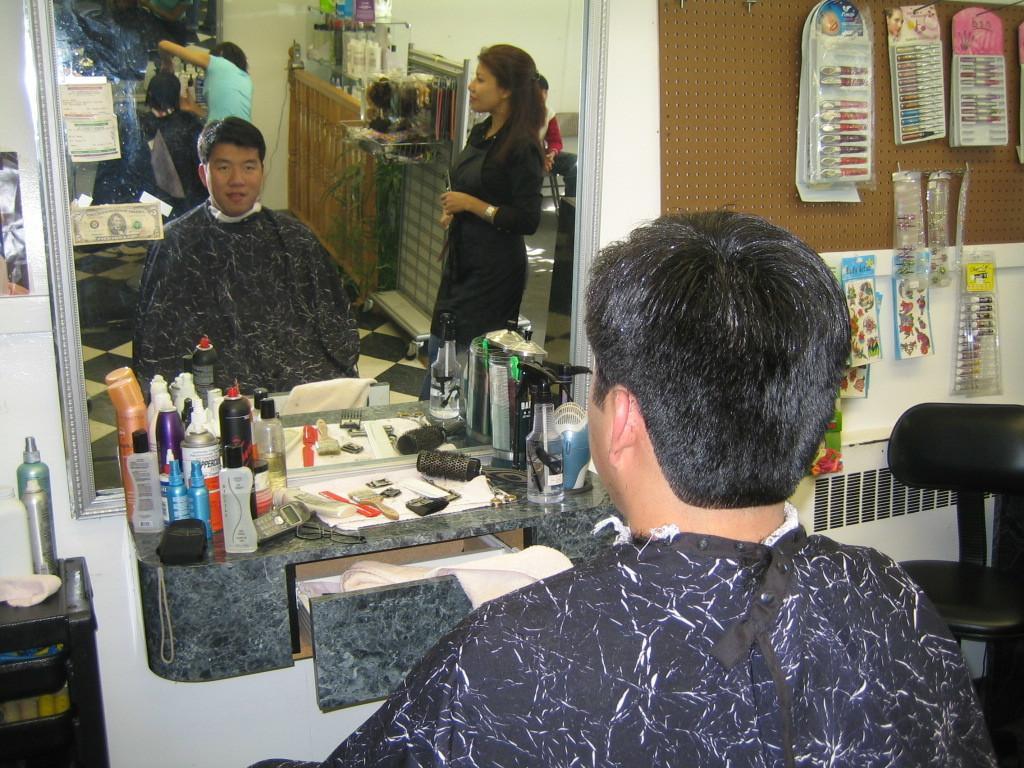Can you describe this image briefly? In this picture we can see a man who is sitting on the chair. This is the mirror. On the mirror we can see two persons standing on the floor. These are the bottles and this is the chair. 